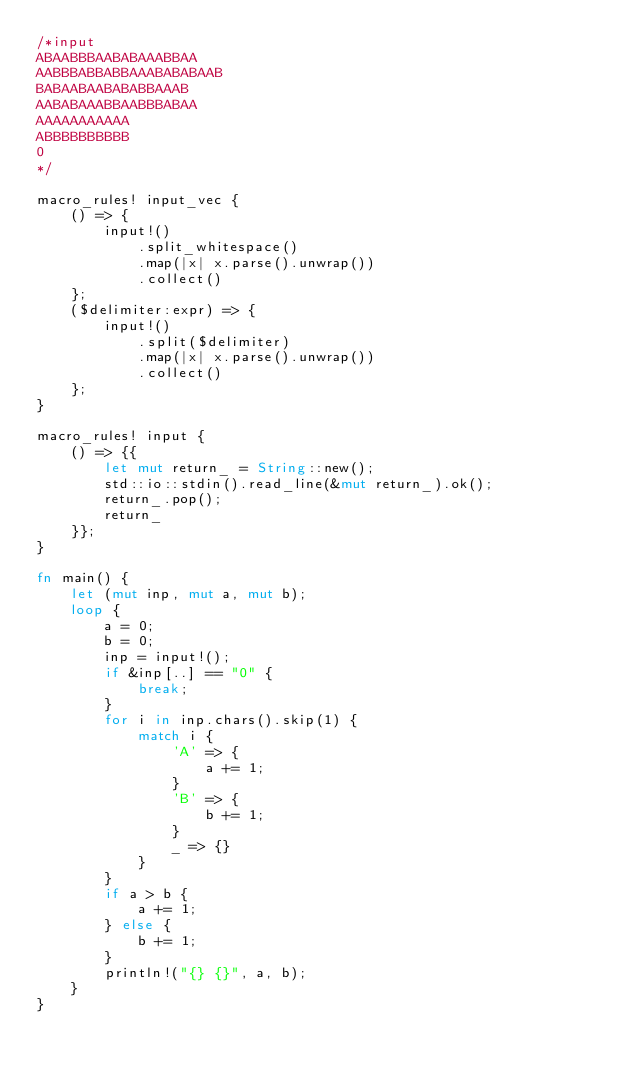<code> <loc_0><loc_0><loc_500><loc_500><_Rust_>/*input
ABAABBBAABABAAABBAA
AABBBABBABBAAABABABAAB
BABAABAABABABBAAAB
AABABAAABBAABBBABAA
AAAAAAAAAAA
ABBBBBBBBBB
0
*/

macro_rules! input_vec {
    () => {
        input!()
            .split_whitespace()
            .map(|x| x.parse().unwrap())
            .collect()
    };
    ($delimiter:expr) => {
        input!()
            .split($delimiter)
            .map(|x| x.parse().unwrap())
            .collect()
    };
}

macro_rules! input {
    () => {{
        let mut return_ = String::new();
        std::io::stdin().read_line(&mut return_).ok();
        return_.pop();
        return_
    }};
}

fn main() {
    let (mut inp, mut a, mut b);
    loop {
        a = 0;
        b = 0;
        inp = input!();
        if &inp[..] == "0" {
            break;
        }
        for i in inp.chars().skip(1) {
            match i {
                'A' => {
                    a += 1;
                }
                'B' => {
                    b += 1;
                }
                _ => {}
            }
        }
        if a > b {
            a += 1;
        } else {
            b += 1;
        }
        println!("{} {}", a, b);
    }
}

</code> 